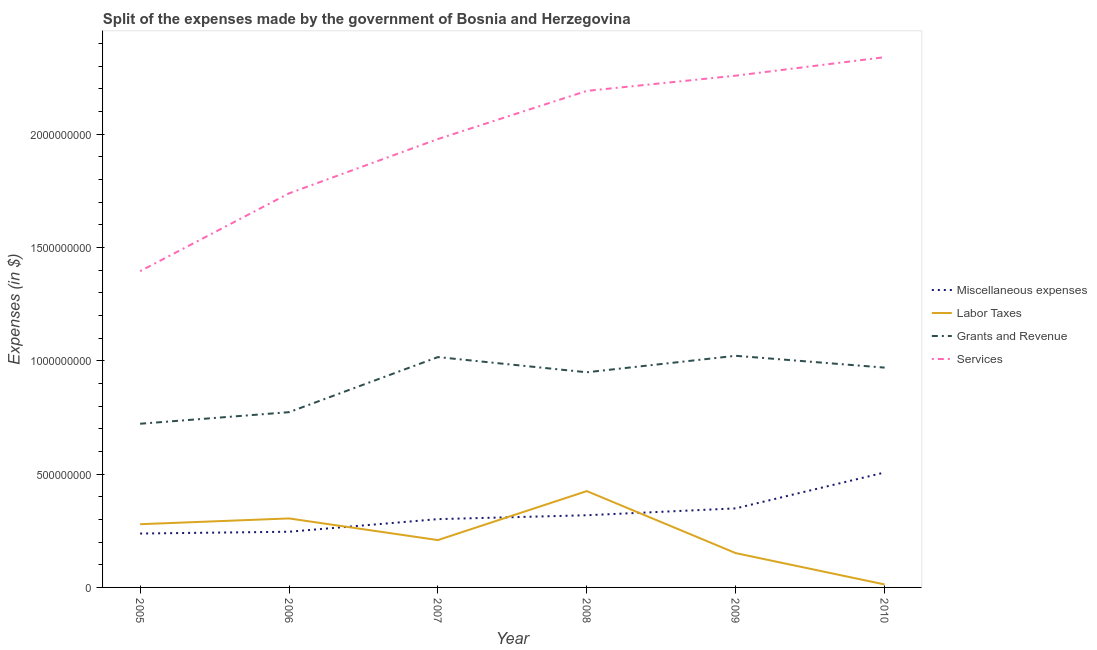How many different coloured lines are there?
Your response must be concise. 4. Is the number of lines equal to the number of legend labels?
Offer a terse response. Yes. What is the amount spent on miscellaneous expenses in 2006?
Your answer should be very brief. 2.46e+08. Across all years, what is the maximum amount spent on services?
Ensure brevity in your answer.  2.34e+09. Across all years, what is the minimum amount spent on grants and revenue?
Your answer should be compact. 7.22e+08. In which year was the amount spent on miscellaneous expenses minimum?
Provide a succinct answer. 2005. What is the total amount spent on labor taxes in the graph?
Offer a very short reply. 1.38e+09. What is the difference between the amount spent on services in 2005 and that in 2010?
Ensure brevity in your answer.  -9.44e+08. What is the difference between the amount spent on grants and revenue in 2009 and the amount spent on services in 2005?
Your answer should be very brief. -3.73e+08. What is the average amount spent on miscellaneous expenses per year?
Your response must be concise. 3.27e+08. In the year 2008, what is the difference between the amount spent on miscellaneous expenses and amount spent on labor taxes?
Your answer should be compact. -1.07e+08. What is the ratio of the amount spent on miscellaneous expenses in 2008 to that in 2010?
Your answer should be compact. 0.63. What is the difference between the highest and the second highest amount spent on miscellaneous expenses?
Keep it short and to the point. 1.58e+08. What is the difference between the highest and the lowest amount spent on grants and revenue?
Make the answer very short. 3.00e+08. Is it the case that in every year, the sum of the amount spent on labor taxes and amount spent on services is greater than the sum of amount spent on miscellaneous expenses and amount spent on grants and revenue?
Make the answer very short. No. Is it the case that in every year, the sum of the amount spent on miscellaneous expenses and amount spent on labor taxes is greater than the amount spent on grants and revenue?
Your answer should be compact. No. Is the amount spent on miscellaneous expenses strictly greater than the amount spent on services over the years?
Your answer should be very brief. No. Is the amount spent on labor taxes strictly less than the amount spent on grants and revenue over the years?
Provide a short and direct response. Yes. How many lines are there?
Offer a terse response. 4. What is the difference between two consecutive major ticks on the Y-axis?
Ensure brevity in your answer.  5.00e+08. Does the graph contain any zero values?
Provide a short and direct response. No. Where does the legend appear in the graph?
Your answer should be very brief. Center right. How many legend labels are there?
Provide a succinct answer. 4. What is the title of the graph?
Your response must be concise. Split of the expenses made by the government of Bosnia and Herzegovina. What is the label or title of the X-axis?
Provide a succinct answer. Year. What is the label or title of the Y-axis?
Provide a succinct answer. Expenses (in $). What is the Expenses (in $) of Miscellaneous expenses in 2005?
Your answer should be compact. 2.38e+08. What is the Expenses (in $) of Labor Taxes in 2005?
Offer a terse response. 2.79e+08. What is the Expenses (in $) in Grants and Revenue in 2005?
Provide a short and direct response. 7.22e+08. What is the Expenses (in $) in Services in 2005?
Give a very brief answer. 1.40e+09. What is the Expenses (in $) in Miscellaneous expenses in 2006?
Your answer should be very brief. 2.46e+08. What is the Expenses (in $) in Labor Taxes in 2006?
Your response must be concise. 3.04e+08. What is the Expenses (in $) of Grants and Revenue in 2006?
Keep it short and to the point. 7.73e+08. What is the Expenses (in $) in Services in 2006?
Your answer should be very brief. 1.74e+09. What is the Expenses (in $) of Miscellaneous expenses in 2007?
Make the answer very short. 3.01e+08. What is the Expenses (in $) of Labor Taxes in 2007?
Ensure brevity in your answer.  2.09e+08. What is the Expenses (in $) of Grants and Revenue in 2007?
Provide a short and direct response. 1.02e+09. What is the Expenses (in $) of Services in 2007?
Your answer should be very brief. 1.98e+09. What is the Expenses (in $) in Miscellaneous expenses in 2008?
Make the answer very short. 3.19e+08. What is the Expenses (in $) in Labor Taxes in 2008?
Your answer should be compact. 4.25e+08. What is the Expenses (in $) of Grants and Revenue in 2008?
Provide a succinct answer. 9.49e+08. What is the Expenses (in $) in Services in 2008?
Your answer should be very brief. 2.19e+09. What is the Expenses (in $) in Miscellaneous expenses in 2009?
Ensure brevity in your answer.  3.49e+08. What is the Expenses (in $) in Labor Taxes in 2009?
Offer a terse response. 1.51e+08. What is the Expenses (in $) in Grants and Revenue in 2009?
Your answer should be compact. 1.02e+09. What is the Expenses (in $) in Services in 2009?
Offer a very short reply. 2.26e+09. What is the Expenses (in $) of Miscellaneous expenses in 2010?
Give a very brief answer. 5.07e+08. What is the Expenses (in $) in Labor Taxes in 2010?
Ensure brevity in your answer.  1.32e+07. What is the Expenses (in $) in Grants and Revenue in 2010?
Offer a very short reply. 9.70e+08. What is the Expenses (in $) in Services in 2010?
Keep it short and to the point. 2.34e+09. Across all years, what is the maximum Expenses (in $) of Miscellaneous expenses?
Offer a very short reply. 5.07e+08. Across all years, what is the maximum Expenses (in $) of Labor Taxes?
Give a very brief answer. 4.25e+08. Across all years, what is the maximum Expenses (in $) in Grants and Revenue?
Your response must be concise. 1.02e+09. Across all years, what is the maximum Expenses (in $) in Services?
Give a very brief answer. 2.34e+09. Across all years, what is the minimum Expenses (in $) of Miscellaneous expenses?
Ensure brevity in your answer.  2.38e+08. Across all years, what is the minimum Expenses (in $) of Labor Taxes?
Offer a terse response. 1.32e+07. Across all years, what is the minimum Expenses (in $) of Grants and Revenue?
Your response must be concise. 7.22e+08. Across all years, what is the minimum Expenses (in $) in Services?
Provide a succinct answer. 1.40e+09. What is the total Expenses (in $) in Miscellaneous expenses in the graph?
Provide a succinct answer. 1.96e+09. What is the total Expenses (in $) in Labor Taxes in the graph?
Provide a succinct answer. 1.38e+09. What is the total Expenses (in $) in Grants and Revenue in the graph?
Your answer should be very brief. 5.45e+09. What is the total Expenses (in $) of Services in the graph?
Offer a very short reply. 1.19e+1. What is the difference between the Expenses (in $) in Miscellaneous expenses in 2005 and that in 2006?
Offer a terse response. -7.90e+06. What is the difference between the Expenses (in $) in Labor Taxes in 2005 and that in 2006?
Provide a succinct answer. -2.55e+07. What is the difference between the Expenses (in $) of Grants and Revenue in 2005 and that in 2006?
Give a very brief answer. -5.11e+07. What is the difference between the Expenses (in $) in Services in 2005 and that in 2006?
Offer a terse response. -3.43e+08. What is the difference between the Expenses (in $) of Miscellaneous expenses in 2005 and that in 2007?
Your answer should be compact. -6.36e+07. What is the difference between the Expenses (in $) in Labor Taxes in 2005 and that in 2007?
Your answer should be compact. 7.00e+07. What is the difference between the Expenses (in $) in Grants and Revenue in 2005 and that in 2007?
Provide a succinct answer. -2.94e+08. What is the difference between the Expenses (in $) of Services in 2005 and that in 2007?
Keep it short and to the point. -5.83e+08. What is the difference between the Expenses (in $) in Miscellaneous expenses in 2005 and that in 2008?
Keep it short and to the point. -8.07e+07. What is the difference between the Expenses (in $) of Labor Taxes in 2005 and that in 2008?
Give a very brief answer. -1.46e+08. What is the difference between the Expenses (in $) of Grants and Revenue in 2005 and that in 2008?
Give a very brief answer. -2.27e+08. What is the difference between the Expenses (in $) in Services in 2005 and that in 2008?
Your response must be concise. -7.96e+08. What is the difference between the Expenses (in $) of Miscellaneous expenses in 2005 and that in 2009?
Offer a very short reply. -1.11e+08. What is the difference between the Expenses (in $) of Labor Taxes in 2005 and that in 2009?
Your answer should be very brief. 1.28e+08. What is the difference between the Expenses (in $) of Grants and Revenue in 2005 and that in 2009?
Your answer should be very brief. -3.00e+08. What is the difference between the Expenses (in $) of Services in 2005 and that in 2009?
Ensure brevity in your answer.  -8.63e+08. What is the difference between the Expenses (in $) of Miscellaneous expenses in 2005 and that in 2010?
Keep it short and to the point. -2.69e+08. What is the difference between the Expenses (in $) in Labor Taxes in 2005 and that in 2010?
Provide a succinct answer. 2.66e+08. What is the difference between the Expenses (in $) in Grants and Revenue in 2005 and that in 2010?
Your answer should be compact. -2.48e+08. What is the difference between the Expenses (in $) in Services in 2005 and that in 2010?
Give a very brief answer. -9.44e+08. What is the difference between the Expenses (in $) in Miscellaneous expenses in 2006 and that in 2007?
Offer a very short reply. -5.57e+07. What is the difference between the Expenses (in $) in Labor Taxes in 2006 and that in 2007?
Keep it short and to the point. 9.55e+07. What is the difference between the Expenses (in $) of Grants and Revenue in 2006 and that in 2007?
Give a very brief answer. -2.43e+08. What is the difference between the Expenses (in $) in Services in 2006 and that in 2007?
Give a very brief answer. -2.40e+08. What is the difference between the Expenses (in $) of Miscellaneous expenses in 2006 and that in 2008?
Your response must be concise. -7.28e+07. What is the difference between the Expenses (in $) in Labor Taxes in 2006 and that in 2008?
Offer a very short reply. -1.21e+08. What is the difference between the Expenses (in $) of Grants and Revenue in 2006 and that in 2008?
Offer a very short reply. -1.76e+08. What is the difference between the Expenses (in $) of Services in 2006 and that in 2008?
Provide a short and direct response. -4.52e+08. What is the difference between the Expenses (in $) in Miscellaneous expenses in 2006 and that in 2009?
Your answer should be compact. -1.03e+08. What is the difference between the Expenses (in $) of Labor Taxes in 2006 and that in 2009?
Provide a succinct answer. 1.53e+08. What is the difference between the Expenses (in $) in Grants and Revenue in 2006 and that in 2009?
Provide a succinct answer. -2.49e+08. What is the difference between the Expenses (in $) of Services in 2006 and that in 2009?
Your answer should be very brief. -5.19e+08. What is the difference between the Expenses (in $) of Miscellaneous expenses in 2006 and that in 2010?
Ensure brevity in your answer.  -2.61e+08. What is the difference between the Expenses (in $) in Labor Taxes in 2006 and that in 2010?
Offer a very short reply. 2.91e+08. What is the difference between the Expenses (in $) of Grants and Revenue in 2006 and that in 2010?
Keep it short and to the point. -1.97e+08. What is the difference between the Expenses (in $) of Services in 2006 and that in 2010?
Your answer should be very brief. -6.01e+08. What is the difference between the Expenses (in $) in Miscellaneous expenses in 2007 and that in 2008?
Offer a very short reply. -1.71e+07. What is the difference between the Expenses (in $) in Labor Taxes in 2007 and that in 2008?
Your answer should be compact. -2.16e+08. What is the difference between the Expenses (in $) in Grants and Revenue in 2007 and that in 2008?
Give a very brief answer. 6.70e+07. What is the difference between the Expenses (in $) of Services in 2007 and that in 2008?
Keep it short and to the point. -2.13e+08. What is the difference between the Expenses (in $) of Miscellaneous expenses in 2007 and that in 2009?
Give a very brief answer. -4.74e+07. What is the difference between the Expenses (in $) of Labor Taxes in 2007 and that in 2009?
Give a very brief answer. 5.75e+07. What is the difference between the Expenses (in $) in Grants and Revenue in 2007 and that in 2009?
Make the answer very short. -5.71e+06. What is the difference between the Expenses (in $) of Services in 2007 and that in 2009?
Your answer should be compact. -2.80e+08. What is the difference between the Expenses (in $) in Miscellaneous expenses in 2007 and that in 2010?
Make the answer very short. -2.06e+08. What is the difference between the Expenses (in $) in Labor Taxes in 2007 and that in 2010?
Your response must be concise. 1.96e+08. What is the difference between the Expenses (in $) of Grants and Revenue in 2007 and that in 2010?
Your response must be concise. 4.64e+07. What is the difference between the Expenses (in $) of Services in 2007 and that in 2010?
Your answer should be very brief. -3.61e+08. What is the difference between the Expenses (in $) in Miscellaneous expenses in 2008 and that in 2009?
Your response must be concise. -3.03e+07. What is the difference between the Expenses (in $) of Labor Taxes in 2008 and that in 2009?
Provide a succinct answer. 2.74e+08. What is the difference between the Expenses (in $) in Grants and Revenue in 2008 and that in 2009?
Provide a short and direct response. -7.27e+07. What is the difference between the Expenses (in $) of Services in 2008 and that in 2009?
Give a very brief answer. -6.71e+07. What is the difference between the Expenses (in $) of Miscellaneous expenses in 2008 and that in 2010?
Offer a very short reply. -1.89e+08. What is the difference between the Expenses (in $) of Labor Taxes in 2008 and that in 2010?
Provide a succinct answer. 4.12e+08. What is the difference between the Expenses (in $) in Grants and Revenue in 2008 and that in 2010?
Offer a very short reply. -2.06e+07. What is the difference between the Expenses (in $) of Services in 2008 and that in 2010?
Make the answer very short. -1.49e+08. What is the difference between the Expenses (in $) of Miscellaneous expenses in 2009 and that in 2010?
Make the answer very short. -1.58e+08. What is the difference between the Expenses (in $) in Labor Taxes in 2009 and that in 2010?
Provide a short and direct response. 1.38e+08. What is the difference between the Expenses (in $) in Grants and Revenue in 2009 and that in 2010?
Provide a succinct answer. 5.21e+07. What is the difference between the Expenses (in $) in Services in 2009 and that in 2010?
Keep it short and to the point. -8.16e+07. What is the difference between the Expenses (in $) of Miscellaneous expenses in 2005 and the Expenses (in $) of Labor Taxes in 2006?
Your answer should be very brief. -6.66e+07. What is the difference between the Expenses (in $) in Miscellaneous expenses in 2005 and the Expenses (in $) in Grants and Revenue in 2006?
Make the answer very short. -5.36e+08. What is the difference between the Expenses (in $) in Miscellaneous expenses in 2005 and the Expenses (in $) in Services in 2006?
Your answer should be very brief. -1.50e+09. What is the difference between the Expenses (in $) in Labor Taxes in 2005 and the Expenses (in $) in Grants and Revenue in 2006?
Make the answer very short. -4.94e+08. What is the difference between the Expenses (in $) of Labor Taxes in 2005 and the Expenses (in $) of Services in 2006?
Your answer should be compact. -1.46e+09. What is the difference between the Expenses (in $) of Grants and Revenue in 2005 and the Expenses (in $) of Services in 2006?
Offer a terse response. -1.02e+09. What is the difference between the Expenses (in $) of Miscellaneous expenses in 2005 and the Expenses (in $) of Labor Taxes in 2007?
Give a very brief answer. 2.89e+07. What is the difference between the Expenses (in $) in Miscellaneous expenses in 2005 and the Expenses (in $) in Grants and Revenue in 2007?
Provide a short and direct response. -7.79e+08. What is the difference between the Expenses (in $) of Miscellaneous expenses in 2005 and the Expenses (in $) of Services in 2007?
Ensure brevity in your answer.  -1.74e+09. What is the difference between the Expenses (in $) in Labor Taxes in 2005 and the Expenses (in $) in Grants and Revenue in 2007?
Give a very brief answer. -7.37e+08. What is the difference between the Expenses (in $) in Labor Taxes in 2005 and the Expenses (in $) in Services in 2007?
Your response must be concise. -1.70e+09. What is the difference between the Expenses (in $) of Grants and Revenue in 2005 and the Expenses (in $) of Services in 2007?
Ensure brevity in your answer.  -1.26e+09. What is the difference between the Expenses (in $) in Miscellaneous expenses in 2005 and the Expenses (in $) in Labor Taxes in 2008?
Ensure brevity in your answer.  -1.87e+08. What is the difference between the Expenses (in $) in Miscellaneous expenses in 2005 and the Expenses (in $) in Grants and Revenue in 2008?
Ensure brevity in your answer.  -7.12e+08. What is the difference between the Expenses (in $) of Miscellaneous expenses in 2005 and the Expenses (in $) of Services in 2008?
Keep it short and to the point. -1.95e+09. What is the difference between the Expenses (in $) in Labor Taxes in 2005 and the Expenses (in $) in Grants and Revenue in 2008?
Provide a succinct answer. -6.70e+08. What is the difference between the Expenses (in $) of Labor Taxes in 2005 and the Expenses (in $) of Services in 2008?
Provide a succinct answer. -1.91e+09. What is the difference between the Expenses (in $) of Grants and Revenue in 2005 and the Expenses (in $) of Services in 2008?
Offer a terse response. -1.47e+09. What is the difference between the Expenses (in $) in Miscellaneous expenses in 2005 and the Expenses (in $) in Labor Taxes in 2009?
Make the answer very short. 8.64e+07. What is the difference between the Expenses (in $) of Miscellaneous expenses in 2005 and the Expenses (in $) of Grants and Revenue in 2009?
Offer a very short reply. -7.84e+08. What is the difference between the Expenses (in $) in Miscellaneous expenses in 2005 and the Expenses (in $) in Services in 2009?
Your response must be concise. -2.02e+09. What is the difference between the Expenses (in $) of Labor Taxes in 2005 and the Expenses (in $) of Grants and Revenue in 2009?
Your answer should be very brief. -7.43e+08. What is the difference between the Expenses (in $) in Labor Taxes in 2005 and the Expenses (in $) in Services in 2009?
Offer a terse response. -1.98e+09. What is the difference between the Expenses (in $) in Grants and Revenue in 2005 and the Expenses (in $) in Services in 2009?
Give a very brief answer. -1.54e+09. What is the difference between the Expenses (in $) in Miscellaneous expenses in 2005 and the Expenses (in $) in Labor Taxes in 2010?
Give a very brief answer. 2.25e+08. What is the difference between the Expenses (in $) in Miscellaneous expenses in 2005 and the Expenses (in $) in Grants and Revenue in 2010?
Your answer should be very brief. -7.32e+08. What is the difference between the Expenses (in $) in Miscellaneous expenses in 2005 and the Expenses (in $) in Services in 2010?
Provide a short and direct response. -2.10e+09. What is the difference between the Expenses (in $) in Labor Taxes in 2005 and the Expenses (in $) in Grants and Revenue in 2010?
Provide a short and direct response. -6.91e+08. What is the difference between the Expenses (in $) of Labor Taxes in 2005 and the Expenses (in $) of Services in 2010?
Provide a succinct answer. -2.06e+09. What is the difference between the Expenses (in $) of Grants and Revenue in 2005 and the Expenses (in $) of Services in 2010?
Provide a succinct answer. -1.62e+09. What is the difference between the Expenses (in $) in Miscellaneous expenses in 2006 and the Expenses (in $) in Labor Taxes in 2007?
Ensure brevity in your answer.  3.68e+07. What is the difference between the Expenses (in $) in Miscellaneous expenses in 2006 and the Expenses (in $) in Grants and Revenue in 2007?
Your answer should be very brief. -7.71e+08. What is the difference between the Expenses (in $) of Miscellaneous expenses in 2006 and the Expenses (in $) of Services in 2007?
Your response must be concise. -1.73e+09. What is the difference between the Expenses (in $) of Labor Taxes in 2006 and the Expenses (in $) of Grants and Revenue in 2007?
Provide a succinct answer. -7.12e+08. What is the difference between the Expenses (in $) in Labor Taxes in 2006 and the Expenses (in $) in Services in 2007?
Provide a succinct answer. -1.67e+09. What is the difference between the Expenses (in $) of Grants and Revenue in 2006 and the Expenses (in $) of Services in 2007?
Offer a very short reply. -1.21e+09. What is the difference between the Expenses (in $) of Miscellaneous expenses in 2006 and the Expenses (in $) of Labor Taxes in 2008?
Offer a terse response. -1.79e+08. What is the difference between the Expenses (in $) in Miscellaneous expenses in 2006 and the Expenses (in $) in Grants and Revenue in 2008?
Offer a terse response. -7.04e+08. What is the difference between the Expenses (in $) in Miscellaneous expenses in 2006 and the Expenses (in $) in Services in 2008?
Ensure brevity in your answer.  -1.95e+09. What is the difference between the Expenses (in $) in Labor Taxes in 2006 and the Expenses (in $) in Grants and Revenue in 2008?
Provide a short and direct response. -6.45e+08. What is the difference between the Expenses (in $) of Labor Taxes in 2006 and the Expenses (in $) of Services in 2008?
Keep it short and to the point. -1.89e+09. What is the difference between the Expenses (in $) of Grants and Revenue in 2006 and the Expenses (in $) of Services in 2008?
Your response must be concise. -1.42e+09. What is the difference between the Expenses (in $) in Miscellaneous expenses in 2006 and the Expenses (in $) in Labor Taxes in 2009?
Your response must be concise. 9.43e+07. What is the difference between the Expenses (in $) in Miscellaneous expenses in 2006 and the Expenses (in $) in Grants and Revenue in 2009?
Your response must be concise. -7.76e+08. What is the difference between the Expenses (in $) of Miscellaneous expenses in 2006 and the Expenses (in $) of Services in 2009?
Your answer should be compact. -2.01e+09. What is the difference between the Expenses (in $) of Labor Taxes in 2006 and the Expenses (in $) of Grants and Revenue in 2009?
Your response must be concise. -7.18e+08. What is the difference between the Expenses (in $) in Labor Taxes in 2006 and the Expenses (in $) in Services in 2009?
Your answer should be compact. -1.95e+09. What is the difference between the Expenses (in $) in Grants and Revenue in 2006 and the Expenses (in $) in Services in 2009?
Provide a short and direct response. -1.48e+09. What is the difference between the Expenses (in $) in Miscellaneous expenses in 2006 and the Expenses (in $) in Labor Taxes in 2010?
Your answer should be compact. 2.33e+08. What is the difference between the Expenses (in $) in Miscellaneous expenses in 2006 and the Expenses (in $) in Grants and Revenue in 2010?
Your answer should be very brief. -7.24e+08. What is the difference between the Expenses (in $) in Miscellaneous expenses in 2006 and the Expenses (in $) in Services in 2010?
Your answer should be compact. -2.09e+09. What is the difference between the Expenses (in $) in Labor Taxes in 2006 and the Expenses (in $) in Grants and Revenue in 2010?
Provide a succinct answer. -6.66e+08. What is the difference between the Expenses (in $) of Labor Taxes in 2006 and the Expenses (in $) of Services in 2010?
Your answer should be compact. -2.04e+09. What is the difference between the Expenses (in $) in Grants and Revenue in 2006 and the Expenses (in $) in Services in 2010?
Ensure brevity in your answer.  -1.57e+09. What is the difference between the Expenses (in $) in Miscellaneous expenses in 2007 and the Expenses (in $) in Labor Taxes in 2008?
Provide a succinct answer. -1.24e+08. What is the difference between the Expenses (in $) of Miscellaneous expenses in 2007 and the Expenses (in $) of Grants and Revenue in 2008?
Your response must be concise. -6.48e+08. What is the difference between the Expenses (in $) of Miscellaneous expenses in 2007 and the Expenses (in $) of Services in 2008?
Offer a terse response. -1.89e+09. What is the difference between the Expenses (in $) of Labor Taxes in 2007 and the Expenses (in $) of Grants and Revenue in 2008?
Provide a short and direct response. -7.40e+08. What is the difference between the Expenses (in $) of Labor Taxes in 2007 and the Expenses (in $) of Services in 2008?
Your answer should be very brief. -1.98e+09. What is the difference between the Expenses (in $) of Grants and Revenue in 2007 and the Expenses (in $) of Services in 2008?
Your answer should be very brief. -1.17e+09. What is the difference between the Expenses (in $) in Miscellaneous expenses in 2007 and the Expenses (in $) in Labor Taxes in 2009?
Give a very brief answer. 1.50e+08. What is the difference between the Expenses (in $) of Miscellaneous expenses in 2007 and the Expenses (in $) of Grants and Revenue in 2009?
Your answer should be very brief. -7.21e+08. What is the difference between the Expenses (in $) in Miscellaneous expenses in 2007 and the Expenses (in $) in Services in 2009?
Offer a very short reply. -1.96e+09. What is the difference between the Expenses (in $) in Labor Taxes in 2007 and the Expenses (in $) in Grants and Revenue in 2009?
Your response must be concise. -8.13e+08. What is the difference between the Expenses (in $) in Labor Taxes in 2007 and the Expenses (in $) in Services in 2009?
Offer a terse response. -2.05e+09. What is the difference between the Expenses (in $) in Grants and Revenue in 2007 and the Expenses (in $) in Services in 2009?
Your answer should be very brief. -1.24e+09. What is the difference between the Expenses (in $) of Miscellaneous expenses in 2007 and the Expenses (in $) of Labor Taxes in 2010?
Your answer should be very brief. 2.88e+08. What is the difference between the Expenses (in $) in Miscellaneous expenses in 2007 and the Expenses (in $) in Grants and Revenue in 2010?
Provide a succinct answer. -6.69e+08. What is the difference between the Expenses (in $) of Miscellaneous expenses in 2007 and the Expenses (in $) of Services in 2010?
Provide a short and direct response. -2.04e+09. What is the difference between the Expenses (in $) of Labor Taxes in 2007 and the Expenses (in $) of Grants and Revenue in 2010?
Give a very brief answer. -7.61e+08. What is the difference between the Expenses (in $) in Labor Taxes in 2007 and the Expenses (in $) in Services in 2010?
Your answer should be very brief. -2.13e+09. What is the difference between the Expenses (in $) of Grants and Revenue in 2007 and the Expenses (in $) of Services in 2010?
Provide a succinct answer. -1.32e+09. What is the difference between the Expenses (in $) in Miscellaneous expenses in 2008 and the Expenses (in $) in Labor Taxes in 2009?
Offer a very short reply. 1.67e+08. What is the difference between the Expenses (in $) in Miscellaneous expenses in 2008 and the Expenses (in $) in Grants and Revenue in 2009?
Offer a very short reply. -7.04e+08. What is the difference between the Expenses (in $) in Miscellaneous expenses in 2008 and the Expenses (in $) in Services in 2009?
Make the answer very short. -1.94e+09. What is the difference between the Expenses (in $) of Labor Taxes in 2008 and the Expenses (in $) of Grants and Revenue in 2009?
Give a very brief answer. -5.97e+08. What is the difference between the Expenses (in $) of Labor Taxes in 2008 and the Expenses (in $) of Services in 2009?
Ensure brevity in your answer.  -1.83e+09. What is the difference between the Expenses (in $) in Grants and Revenue in 2008 and the Expenses (in $) in Services in 2009?
Offer a terse response. -1.31e+09. What is the difference between the Expenses (in $) of Miscellaneous expenses in 2008 and the Expenses (in $) of Labor Taxes in 2010?
Keep it short and to the point. 3.05e+08. What is the difference between the Expenses (in $) of Miscellaneous expenses in 2008 and the Expenses (in $) of Grants and Revenue in 2010?
Your answer should be compact. -6.51e+08. What is the difference between the Expenses (in $) of Miscellaneous expenses in 2008 and the Expenses (in $) of Services in 2010?
Your response must be concise. -2.02e+09. What is the difference between the Expenses (in $) of Labor Taxes in 2008 and the Expenses (in $) of Grants and Revenue in 2010?
Provide a succinct answer. -5.45e+08. What is the difference between the Expenses (in $) in Labor Taxes in 2008 and the Expenses (in $) in Services in 2010?
Make the answer very short. -1.91e+09. What is the difference between the Expenses (in $) in Grants and Revenue in 2008 and the Expenses (in $) in Services in 2010?
Give a very brief answer. -1.39e+09. What is the difference between the Expenses (in $) of Miscellaneous expenses in 2009 and the Expenses (in $) of Labor Taxes in 2010?
Your answer should be very brief. 3.36e+08. What is the difference between the Expenses (in $) in Miscellaneous expenses in 2009 and the Expenses (in $) in Grants and Revenue in 2010?
Your response must be concise. -6.21e+08. What is the difference between the Expenses (in $) of Miscellaneous expenses in 2009 and the Expenses (in $) of Services in 2010?
Your answer should be compact. -1.99e+09. What is the difference between the Expenses (in $) in Labor Taxes in 2009 and the Expenses (in $) in Grants and Revenue in 2010?
Offer a very short reply. -8.19e+08. What is the difference between the Expenses (in $) in Labor Taxes in 2009 and the Expenses (in $) in Services in 2010?
Provide a short and direct response. -2.19e+09. What is the difference between the Expenses (in $) in Grants and Revenue in 2009 and the Expenses (in $) in Services in 2010?
Provide a succinct answer. -1.32e+09. What is the average Expenses (in $) in Miscellaneous expenses per year?
Your response must be concise. 3.27e+08. What is the average Expenses (in $) in Labor Taxes per year?
Keep it short and to the point. 2.30e+08. What is the average Expenses (in $) of Grants and Revenue per year?
Offer a very short reply. 9.09e+08. What is the average Expenses (in $) of Services per year?
Provide a succinct answer. 1.98e+09. In the year 2005, what is the difference between the Expenses (in $) in Miscellaneous expenses and Expenses (in $) in Labor Taxes?
Your answer should be compact. -4.12e+07. In the year 2005, what is the difference between the Expenses (in $) in Miscellaneous expenses and Expenses (in $) in Grants and Revenue?
Ensure brevity in your answer.  -4.84e+08. In the year 2005, what is the difference between the Expenses (in $) in Miscellaneous expenses and Expenses (in $) in Services?
Your answer should be compact. -1.16e+09. In the year 2005, what is the difference between the Expenses (in $) in Labor Taxes and Expenses (in $) in Grants and Revenue?
Offer a terse response. -4.43e+08. In the year 2005, what is the difference between the Expenses (in $) in Labor Taxes and Expenses (in $) in Services?
Offer a very short reply. -1.12e+09. In the year 2005, what is the difference between the Expenses (in $) of Grants and Revenue and Expenses (in $) of Services?
Ensure brevity in your answer.  -6.73e+08. In the year 2006, what is the difference between the Expenses (in $) in Miscellaneous expenses and Expenses (in $) in Labor Taxes?
Your response must be concise. -5.87e+07. In the year 2006, what is the difference between the Expenses (in $) in Miscellaneous expenses and Expenses (in $) in Grants and Revenue?
Make the answer very short. -5.28e+08. In the year 2006, what is the difference between the Expenses (in $) of Miscellaneous expenses and Expenses (in $) of Services?
Ensure brevity in your answer.  -1.49e+09. In the year 2006, what is the difference between the Expenses (in $) of Labor Taxes and Expenses (in $) of Grants and Revenue?
Offer a terse response. -4.69e+08. In the year 2006, what is the difference between the Expenses (in $) of Labor Taxes and Expenses (in $) of Services?
Provide a succinct answer. -1.43e+09. In the year 2006, what is the difference between the Expenses (in $) in Grants and Revenue and Expenses (in $) in Services?
Give a very brief answer. -9.66e+08. In the year 2007, what is the difference between the Expenses (in $) of Miscellaneous expenses and Expenses (in $) of Labor Taxes?
Your answer should be compact. 9.25e+07. In the year 2007, what is the difference between the Expenses (in $) in Miscellaneous expenses and Expenses (in $) in Grants and Revenue?
Give a very brief answer. -7.15e+08. In the year 2007, what is the difference between the Expenses (in $) in Miscellaneous expenses and Expenses (in $) in Services?
Ensure brevity in your answer.  -1.68e+09. In the year 2007, what is the difference between the Expenses (in $) of Labor Taxes and Expenses (in $) of Grants and Revenue?
Keep it short and to the point. -8.07e+08. In the year 2007, what is the difference between the Expenses (in $) in Labor Taxes and Expenses (in $) in Services?
Your answer should be very brief. -1.77e+09. In the year 2007, what is the difference between the Expenses (in $) of Grants and Revenue and Expenses (in $) of Services?
Provide a succinct answer. -9.62e+08. In the year 2008, what is the difference between the Expenses (in $) of Miscellaneous expenses and Expenses (in $) of Labor Taxes?
Your answer should be compact. -1.07e+08. In the year 2008, what is the difference between the Expenses (in $) in Miscellaneous expenses and Expenses (in $) in Grants and Revenue?
Ensure brevity in your answer.  -6.31e+08. In the year 2008, what is the difference between the Expenses (in $) of Miscellaneous expenses and Expenses (in $) of Services?
Your answer should be compact. -1.87e+09. In the year 2008, what is the difference between the Expenses (in $) of Labor Taxes and Expenses (in $) of Grants and Revenue?
Give a very brief answer. -5.24e+08. In the year 2008, what is the difference between the Expenses (in $) in Labor Taxes and Expenses (in $) in Services?
Offer a very short reply. -1.77e+09. In the year 2008, what is the difference between the Expenses (in $) in Grants and Revenue and Expenses (in $) in Services?
Provide a succinct answer. -1.24e+09. In the year 2009, what is the difference between the Expenses (in $) in Miscellaneous expenses and Expenses (in $) in Labor Taxes?
Provide a short and direct response. 1.97e+08. In the year 2009, what is the difference between the Expenses (in $) in Miscellaneous expenses and Expenses (in $) in Grants and Revenue?
Make the answer very short. -6.73e+08. In the year 2009, what is the difference between the Expenses (in $) in Miscellaneous expenses and Expenses (in $) in Services?
Keep it short and to the point. -1.91e+09. In the year 2009, what is the difference between the Expenses (in $) of Labor Taxes and Expenses (in $) of Grants and Revenue?
Your response must be concise. -8.71e+08. In the year 2009, what is the difference between the Expenses (in $) in Labor Taxes and Expenses (in $) in Services?
Ensure brevity in your answer.  -2.11e+09. In the year 2009, what is the difference between the Expenses (in $) in Grants and Revenue and Expenses (in $) in Services?
Ensure brevity in your answer.  -1.24e+09. In the year 2010, what is the difference between the Expenses (in $) of Miscellaneous expenses and Expenses (in $) of Labor Taxes?
Your response must be concise. 4.94e+08. In the year 2010, what is the difference between the Expenses (in $) of Miscellaneous expenses and Expenses (in $) of Grants and Revenue?
Provide a succinct answer. -4.63e+08. In the year 2010, what is the difference between the Expenses (in $) in Miscellaneous expenses and Expenses (in $) in Services?
Make the answer very short. -1.83e+09. In the year 2010, what is the difference between the Expenses (in $) in Labor Taxes and Expenses (in $) in Grants and Revenue?
Provide a short and direct response. -9.57e+08. In the year 2010, what is the difference between the Expenses (in $) in Labor Taxes and Expenses (in $) in Services?
Give a very brief answer. -2.33e+09. In the year 2010, what is the difference between the Expenses (in $) in Grants and Revenue and Expenses (in $) in Services?
Provide a succinct answer. -1.37e+09. What is the ratio of the Expenses (in $) in Miscellaneous expenses in 2005 to that in 2006?
Provide a succinct answer. 0.97. What is the ratio of the Expenses (in $) in Labor Taxes in 2005 to that in 2006?
Provide a short and direct response. 0.92. What is the ratio of the Expenses (in $) in Grants and Revenue in 2005 to that in 2006?
Keep it short and to the point. 0.93. What is the ratio of the Expenses (in $) of Services in 2005 to that in 2006?
Your answer should be very brief. 0.8. What is the ratio of the Expenses (in $) of Miscellaneous expenses in 2005 to that in 2007?
Give a very brief answer. 0.79. What is the ratio of the Expenses (in $) in Labor Taxes in 2005 to that in 2007?
Offer a very short reply. 1.34. What is the ratio of the Expenses (in $) in Grants and Revenue in 2005 to that in 2007?
Offer a terse response. 0.71. What is the ratio of the Expenses (in $) in Services in 2005 to that in 2007?
Keep it short and to the point. 0.71. What is the ratio of the Expenses (in $) in Miscellaneous expenses in 2005 to that in 2008?
Keep it short and to the point. 0.75. What is the ratio of the Expenses (in $) in Labor Taxes in 2005 to that in 2008?
Provide a short and direct response. 0.66. What is the ratio of the Expenses (in $) in Grants and Revenue in 2005 to that in 2008?
Make the answer very short. 0.76. What is the ratio of the Expenses (in $) in Services in 2005 to that in 2008?
Ensure brevity in your answer.  0.64. What is the ratio of the Expenses (in $) of Miscellaneous expenses in 2005 to that in 2009?
Offer a very short reply. 0.68. What is the ratio of the Expenses (in $) in Labor Taxes in 2005 to that in 2009?
Offer a terse response. 1.84. What is the ratio of the Expenses (in $) in Grants and Revenue in 2005 to that in 2009?
Your answer should be very brief. 0.71. What is the ratio of the Expenses (in $) of Services in 2005 to that in 2009?
Provide a short and direct response. 0.62. What is the ratio of the Expenses (in $) in Miscellaneous expenses in 2005 to that in 2010?
Your response must be concise. 0.47. What is the ratio of the Expenses (in $) of Labor Taxes in 2005 to that in 2010?
Your response must be concise. 21.19. What is the ratio of the Expenses (in $) in Grants and Revenue in 2005 to that in 2010?
Your response must be concise. 0.74. What is the ratio of the Expenses (in $) in Services in 2005 to that in 2010?
Give a very brief answer. 0.6. What is the ratio of the Expenses (in $) in Miscellaneous expenses in 2006 to that in 2007?
Give a very brief answer. 0.82. What is the ratio of the Expenses (in $) of Labor Taxes in 2006 to that in 2007?
Your answer should be compact. 1.46. What is the ratio of the Expenses (in $) in Grants and Revenue in 2006 to that in 2007?
Offer a terse response. 0.76. What is the ratio of the Expenses (in $) of Services in 2006 to that in 2007?
Keep it short and to the point. 0.88. What is the ratio of the Expenses (in $) in Miscellaneous expenses in 2006 to that in 2008?
Your response must be concise. 0.77. What is the ratio of the Expenses (in $) of Labor Taxes in 2006 to that in 2008?
Give a very brief answer. 0.72. What is the ratio of the Expenses (in $) in Grants and Revenue in 2006 to that in 2008?
Provide a short and direct response. 0.81. What is the ratio of the Expenses (in $) in Services in 2006 to that in 2008?
Provide a short and direct response. 0.79. What is the ratio of the Expenses (in $) of Miscellaneous expenses in 2006 to that in 2009?
Provide a short and direct response. 0.7. What is the ratio of the Expenses (in $) in Labor Taxes in 2006 to that in 2009?
Offer a terse response. 2.01. What is the ratio of the Expenses (in $) of Grants and Revenue in 2006 to that in 2009?
Give a very brief answer. 0.76. What is the ratio of the Expenses (in $) of Services in 2006 to that in 2009?
Provide a short and direct response. 0.77. What is the ratio of the Expenses (in $) of Miscellaneous expenses in 2006 to that in 2010?
Provide a succinct answer. 0.48. What is the ratio of the Expenses (in $) of Labor Taxes in 2006 to that in 2010?
Your answer should be very brief. 23.13. What is the ratio of the Expenses (in $) in Grants and Revenue in 2006 to that in 2010?
Provide a short and direct response. 0.8. What is the ratio of the Expenses (in $) of Services in 2006 to that in 2010?
Give a very brief answer. 0.74. What is the ratio of the Expenses (in $) in Miscellaneous expenses in 2007 to that in 2008?
Keep it short and to the point. 0.95. What is the ratio of the Expenses (in $) in Labor Taxes in 2007 to that in 2008?
Provide a succinct answer. 0.49. What is the ratio of the Expenses (in $) in Grants and Revenue in 2007 to that in 2008?
Offer a very short reply. 1.07. What is the ratio of the Expenses (in $) in Services in 2007 to that in 2008?
Give a very brief answer. 0.9. What is the ratio of the Expenses (in $) in Miscellaneous expenses in 2007 to that in 2009?
Make the answer very short. 0.86. What is the ratio of the Expenses (in $) in Labor Taxes in 2007 to that in 2009?
Ensure brevity in your answer.  1.38. What is the ratio of the Expenses (in $) in Services in 2007 to that in 2009?
Give a very brief answer. 0.88. What is the ratio of the Expenses (in $) of Miscellaneous expenses in 2007 to that in 2010?
Keep it short and to the point. 0.59. What is the ratio of the Expenses (in $) in Labor Taxes in 2007 to that in 2010?
Ensure brevity in your answer.  15.87. What is the ratio of the Expenses (in $) in Grants and Revenue in 2007 to that in 2010?
Provide a succinct answer. 1.05. What is the ratio of the Expenses (in $) in Services in 2007 to that in 2010?
Make the answer very short. 0.85. What is the ratio of the Expenses (in $) of Miscellaneous expenses in 2008 to that in 2009?
Offer a very short reply. 0.91. What is the ratio of the Expenses (in $) in Labor Taxes in 2008 to that in 2009?
Provide a succinct answer. 2.81. What is the ratio of the Expenses (in $) of Grants and Revenue in 2008 to that in 2009?
Your answer should be compact. 0.93. What is the ratio of the Expenses (in $) of Services in 2008 to that in 2009?
Ensure brevity in your answer.  0.97. What is the ratio of the Expenses (in $) of Miscellaneous expenses in 2008 to that in 2010?
Offer a very short reply. 0.63. What is the ratio of the Expenses (in $) in Labor Taxes in 2008 to that in 2010?
Make the answer very short. 32.29. What is the ratio of the Expenses (in $) in Grants and Revenue in 2008 to that in 2010?
Ensure brevity in your answer.  0.98. What is the ratio of the Expenses (in $) of Services in 2008 to that in 2010?
Keep it short and to the point. 0.94. What is the ratio of the Expenses (in $) in Miscellaneous expenses in 2009 to that in 2010?
Your answer should be compact. 0.69. What is the ratio of the Expenses (in $) of Labor Taxes in 2009 to that in 2010?
Provide a short and direct response. 11.5. What is the ratio of the Expenses (in $) in Grants and Revenue in 2009 to that in 2010?
Offer a very short reply. 1.05. What is the ratio of the Expenses (in $) in Services in 2009 to that in 2010?
Make the answer very short. 0.97. What is the difference between the highest and the second highest Expenses (in $) of Miscellaneous expenses?
Provide a short and direct response. 1.58e+08. What is the difference between the highest and the second highest Expenses (in $) in Labor Taxes?
Provide a succinct answer. 1.21e+08. What is the difference between the highest and the second highest Expenses (in $) in Grants and Revenue?
Provide a succinct answer. 5.71e+06. What is the difference between the highest and the second highest Expenses (in $) of Services?
Provide a succinct answer. 8.16e+07. What is the difference between the highest and the lowest Expenses (in $) in Miscellaneous expenses?
Your response must be concise. 2.69e+08. What is the difference between the highest and the lowest Expenses (in $) in Labor Taxes?
Ensure brevity in your answer.  4.12e+08. What is the difference between the highest and the lowest Expenses (in $) of Grants and Revenue?
Your answer should be very brief. 3.00e+08. What is the difference between the highest and the lowest Expenses (in $) of Services?
Your answer should be very brief. 9.44e+08. 